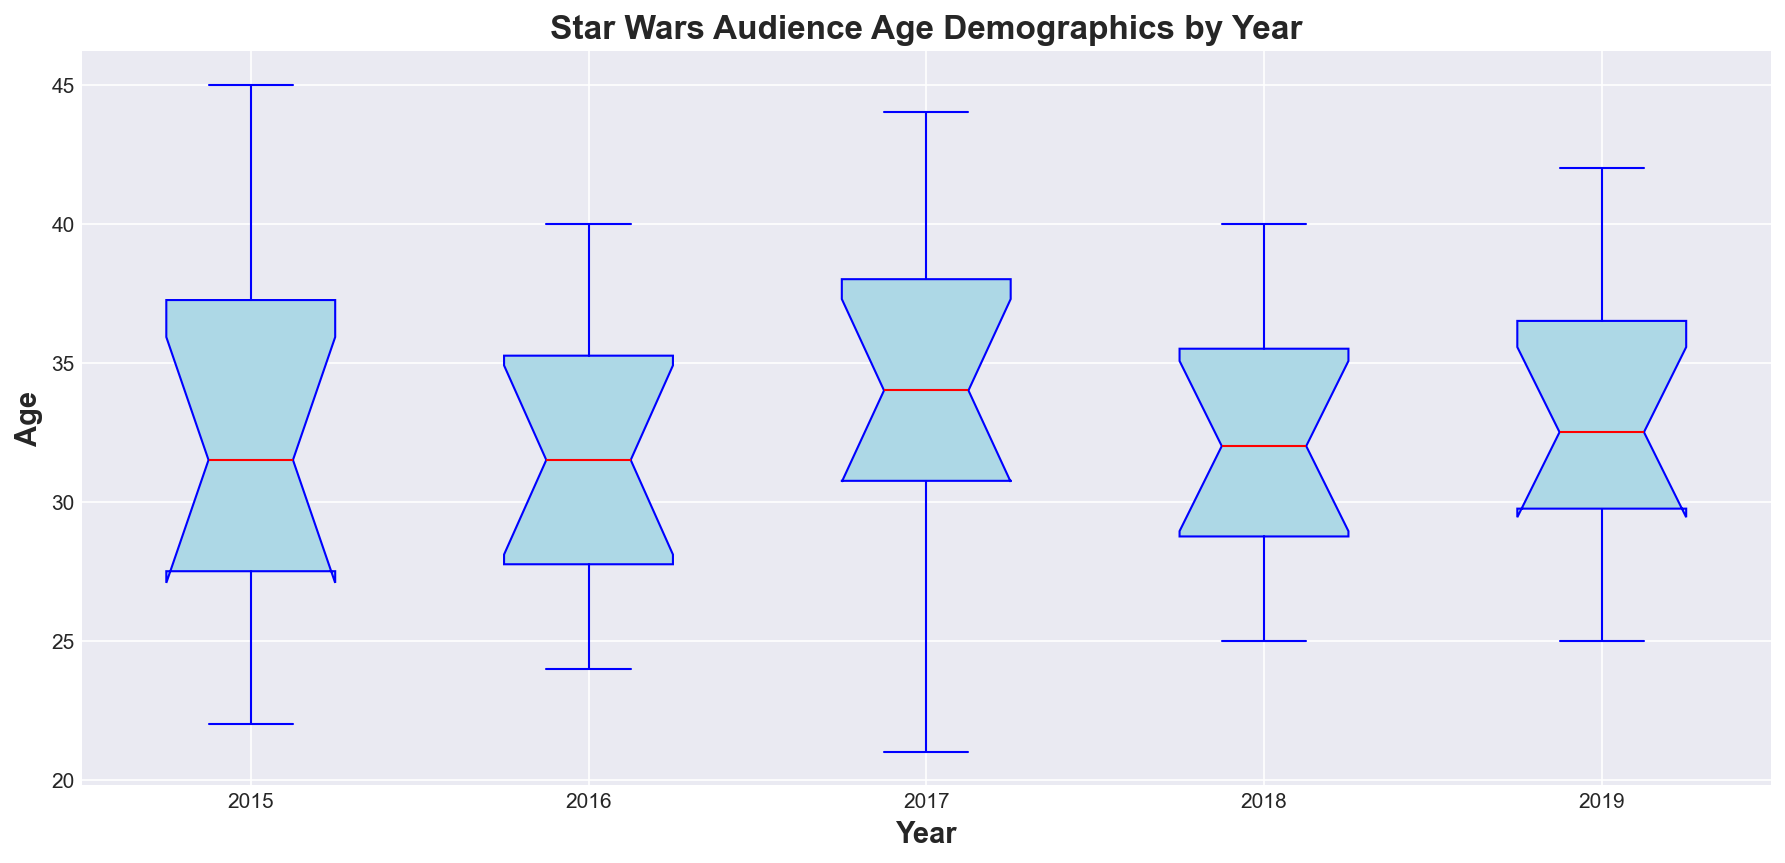What's the median age of Star Wars fans in 2016? First, locate the box for the year 2016. The median is represented by the red line inside the box.
Answer: 32 Which year has the smallest interquartile range for age? The interquartile range (IQR) is the distance between the top and bottom of the box. Identify the year with the shortest box height.
Answer: 2017 In which year did the oldest Star Wars fan appear in the survey? Look for the highest point of the upper whisker across all the years. The highest whisker represents the oldest fan.
Answer: 2017 Compare the median age of fans in 2015 and 2017. Which year had a higher median? Locate the median lines (red lines) for both 2015 and 2017. Compare their vertical positions.
Answer: 2015 How many years have outliers, and what are those years? Outliers are indicated by red circles outside the whiskers. Count and identify the years with these red circles.
Answer: 4 years: 2015, 2016, 2017, 2019 What is the range of ages for Star Wars fans in 2018? The range is calculated by the difference between the highest and lowest points of the whiskers for 2018. Locate and read these points.
Answer: 25 to 40 Are the median ages of fans generally increasing or decreasing over the years? Observe the trend of the red lines representing median ages from 2015 to 2019. Note if the line generally goes up or down.
Answer: Generally stable Which year has the most variability in fan ages? Variability can be seen by identifying the year with the largest distance from the bottom whisker to the top whisker.
Answer: 2017 Do any years have the same median age, and if so, which years? Compare the median lines for all years. Look for years where the red lines are at the same level.
Answer: 2018 and 2019 